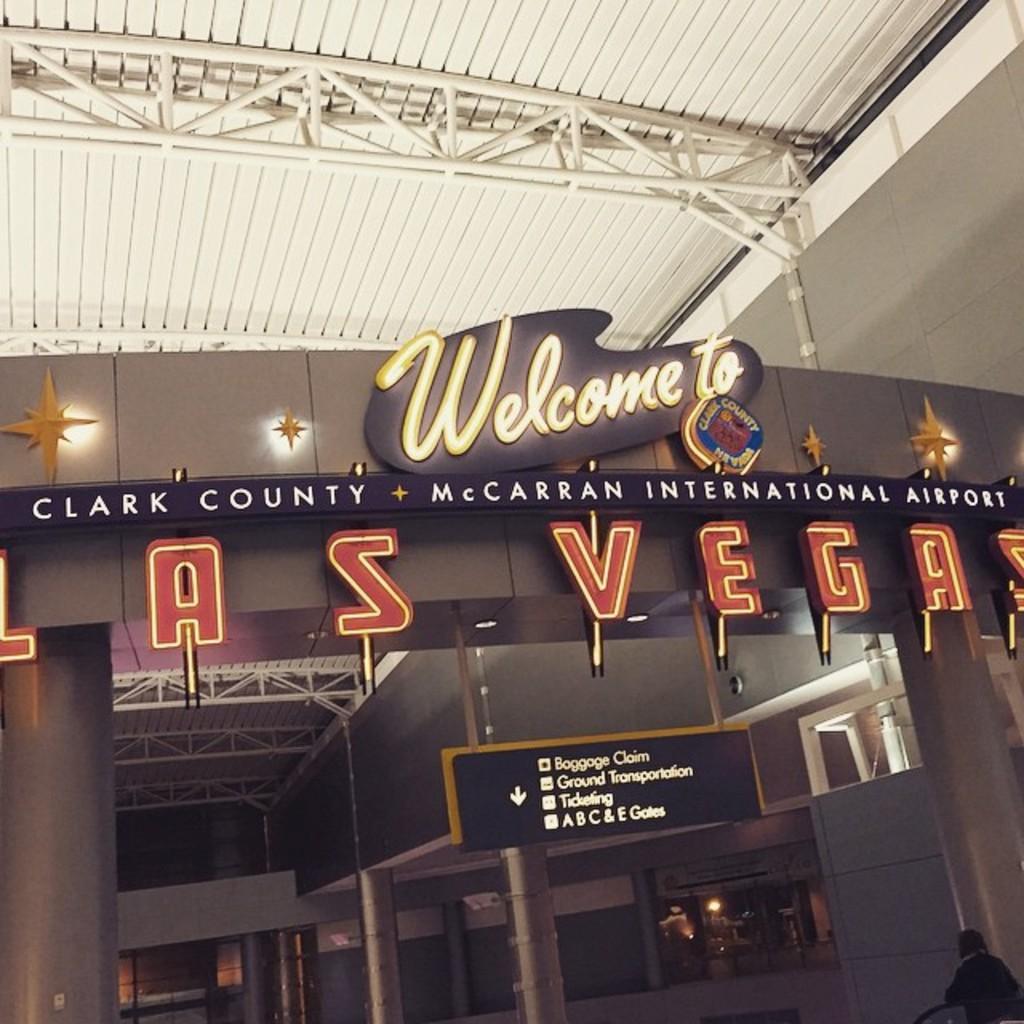How would you summarize this image in a sentence or two? In this picture I can see there is a name board and there is something written on it. There is a person here at right side and there are few pillars and iron frames on the ceiling and there are few lights. 